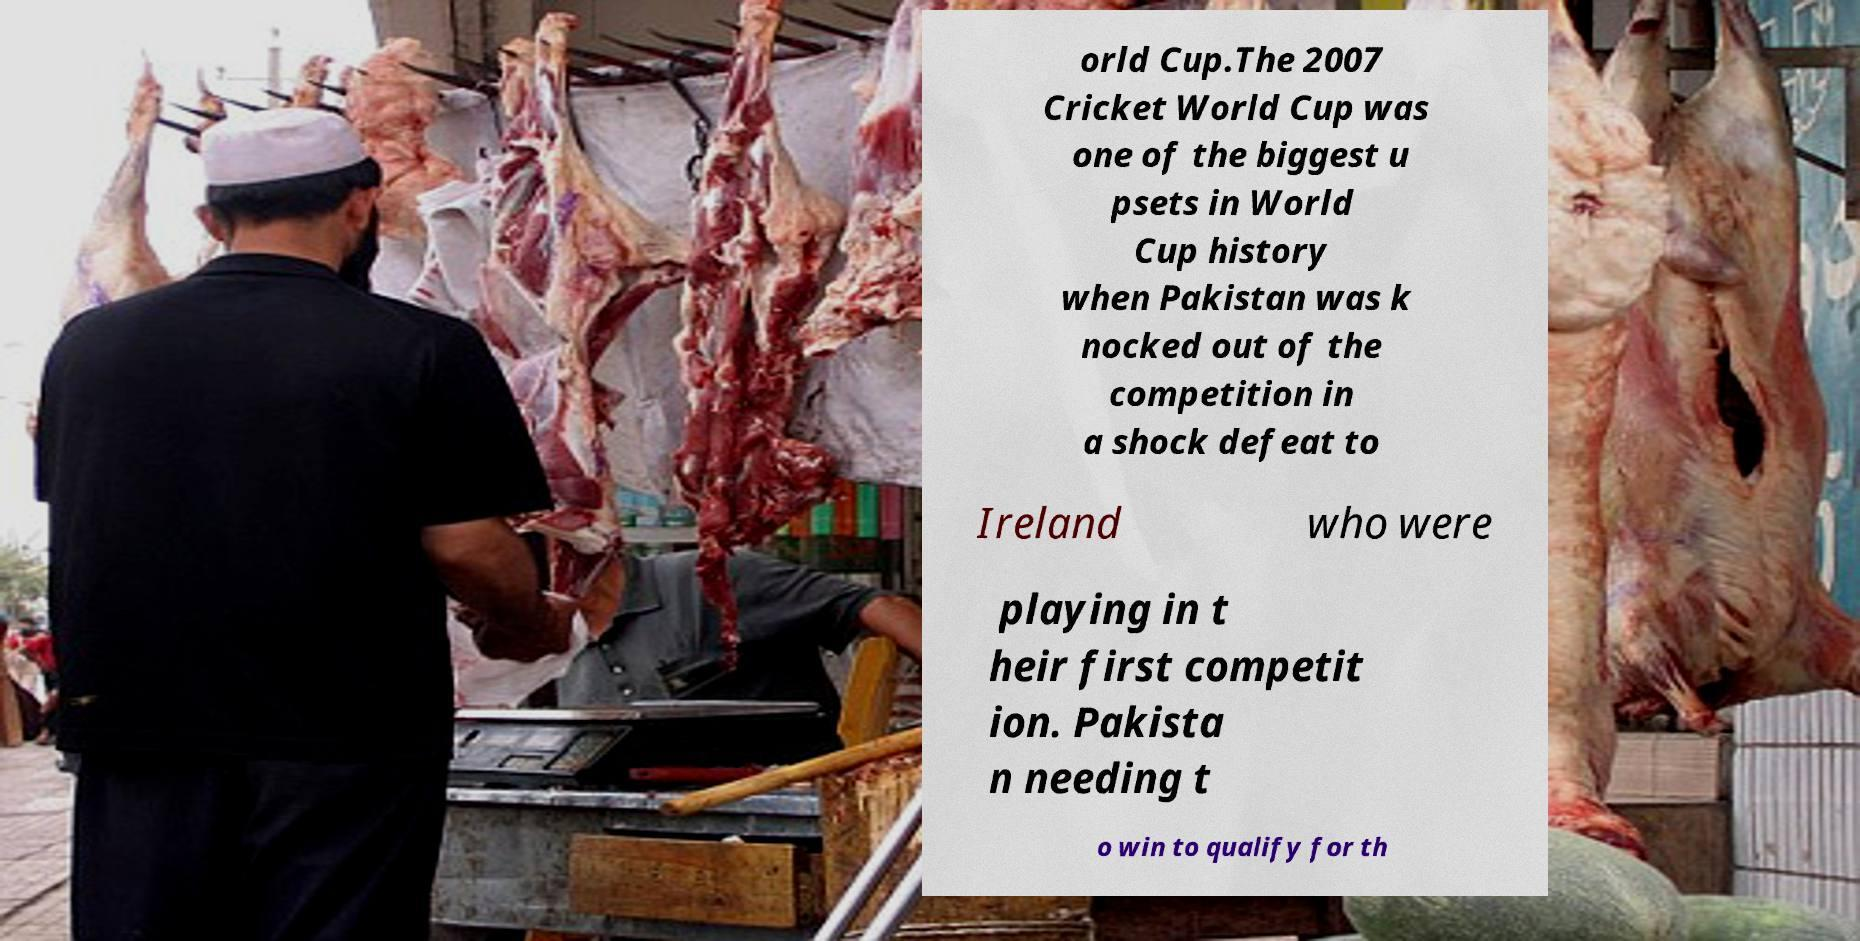Please read and relay the text visible in this image. What does it say? orld Cup.The 2007 Cricket World Cup was one of the biggest u psets in World Cup history when Pakistan was k nocked out of the competition in a shock defeat to Ireland who were playing in t heir first competit ion. Pakista n needing t o win to qualify for th 